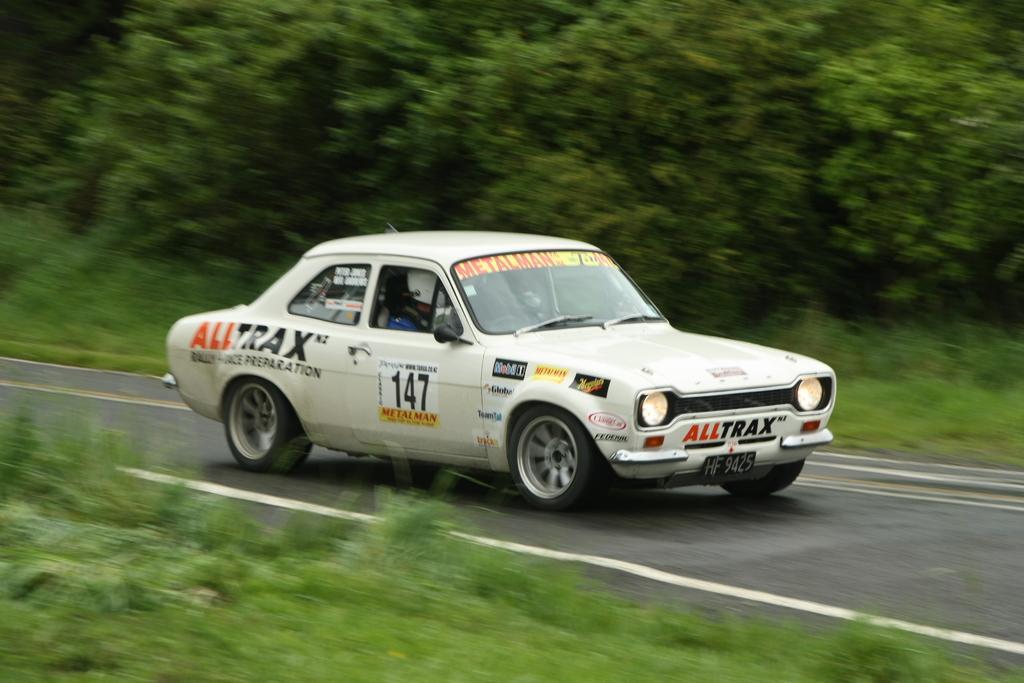Can you describe this image briefly? In this image there is white color car in middle of this image and there is a road as we can see in middle of this image and there are some plants at bottom of this image and there are some trees at top of this image. 